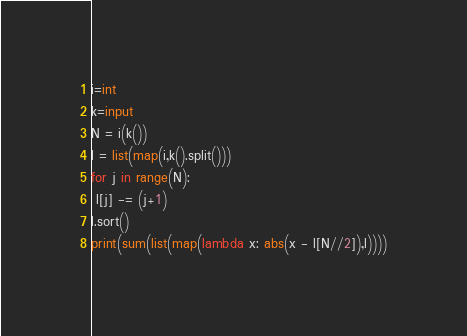Convert code to text. <code><loc_0><loc_0><loc_500><loc_500><_Python_>i=int
k=input
N = i(k())
l = list(map(i,k().split()))
for j in range(N):
 l[j] -= (j+1)
l.sort()
print(sum(list(map(lambda x: abs(x - l[N//2]),l))))</code> 